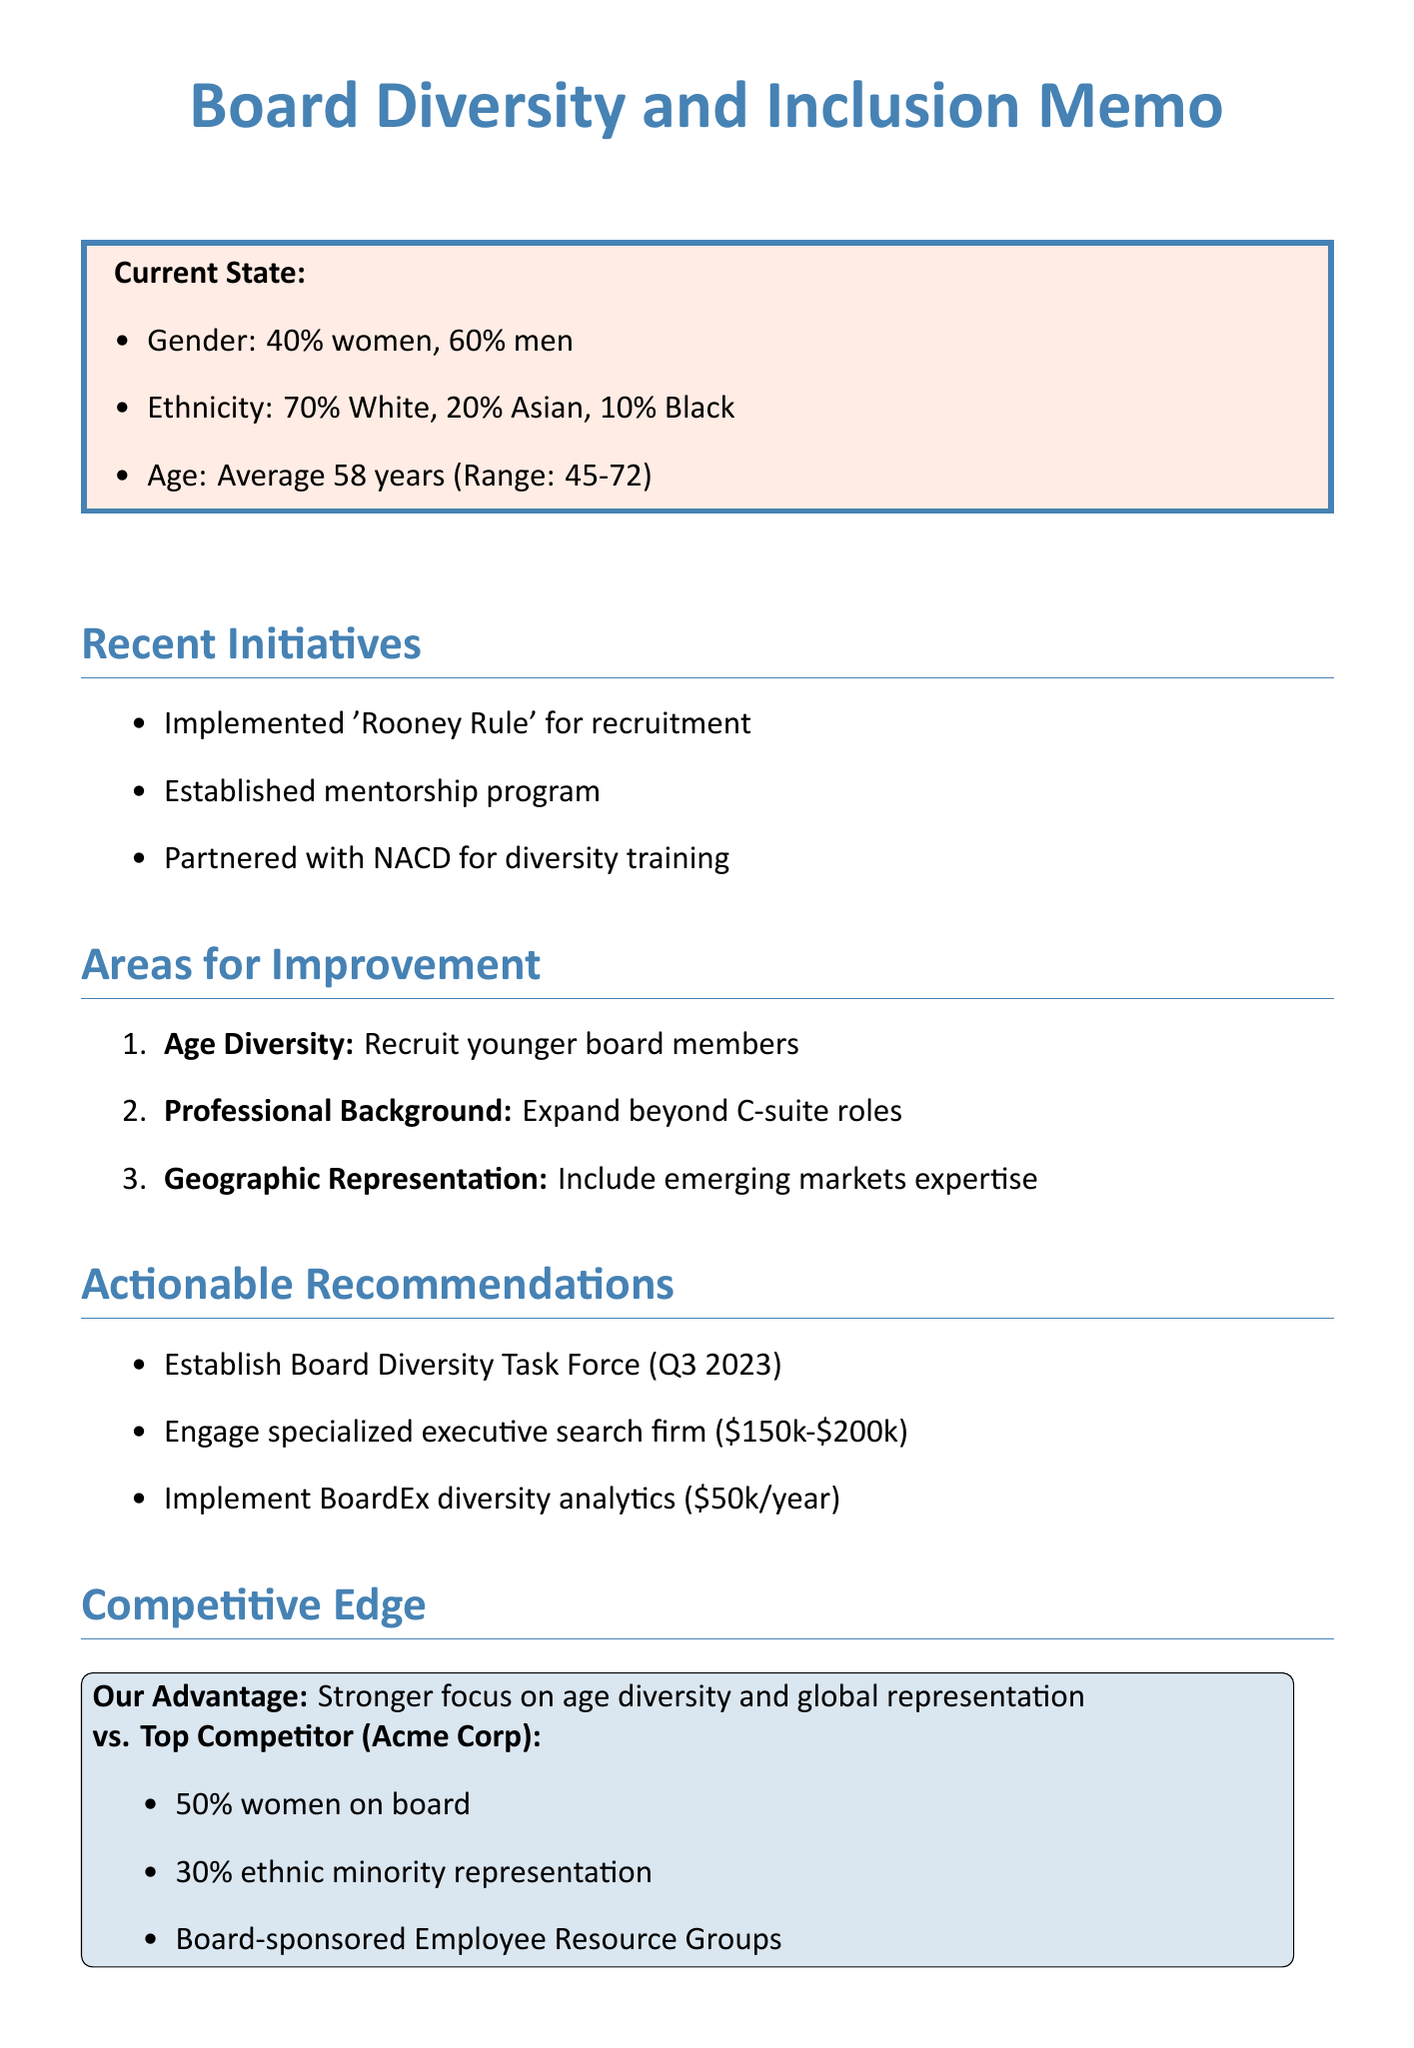What is the gender ratio on the board? The document states the gender ratio is 40% women and 60% men.
Answer: 40% women, 60% men What is the average age of board members? The average age is indicated in the current state section.
Answer: Average age: 58 What initiative focuses on mentorship? The document lists initiatives, one of which is specifically a mentorship program.
Answer: Established mentorship program What is the ethnic diversity percentage of Black board members? The ethnic diversity breakdown includes a specific percentage for Black members.
Answer: 10% Black What is the recommended action for improving age diversity? The suggestions outline a specific recommendation regarding younger board members.
Answer: Actively recruit younger board members Which benchmark company has 50% women on its board? The competitive analysis mentions Acme Corp and its board composition.
Answer: Acme Corp Who is the leader of the proposed Board Diversity Task Force? The actionable recommendations include the leader's name for the task force.
Answer: Sarah Chen What is the budget for engaging an executive search firm? The actionable recommendations section states a specific budget range.
Answer: $150,000 - $200,000 What is the closing statement's primary goal? The closing statement defines the desired outcome of the diversity efforts.
Answer: Position ourselves as industry leaders in board diversity and inclusion 